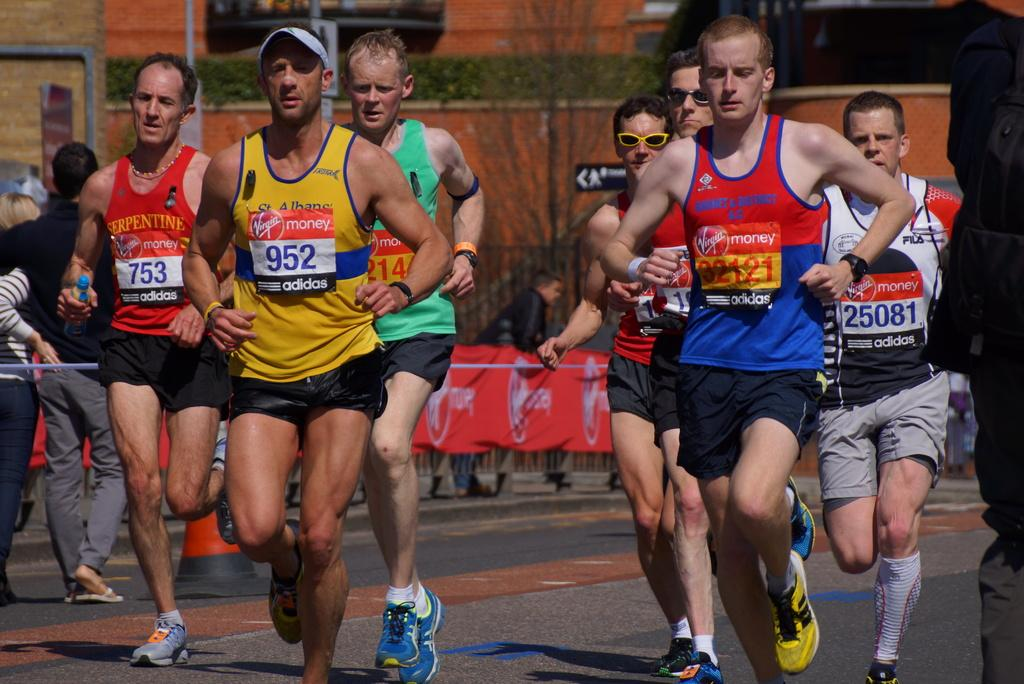<image>
Summarize the visual content of the image. a group of runners running, including number 952 and 25081 